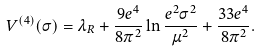Convert formula to latex. <formula><loc_0><loc_0><loc_500><loc_500>V ^ { ( 4 ) } ( \sigma ) = \lambda _ { R } + \frac { 9 e ^ { 4 } } { 8 \pi ^ { 2 } } \ln \frac { e ^ { 2 } \sigma ^ { 2 } } { \mu ^ { 2 } } + \frac { 3 3 e ^ { 4 } } { 8 \pi ^ { 2 } } .</formula> 